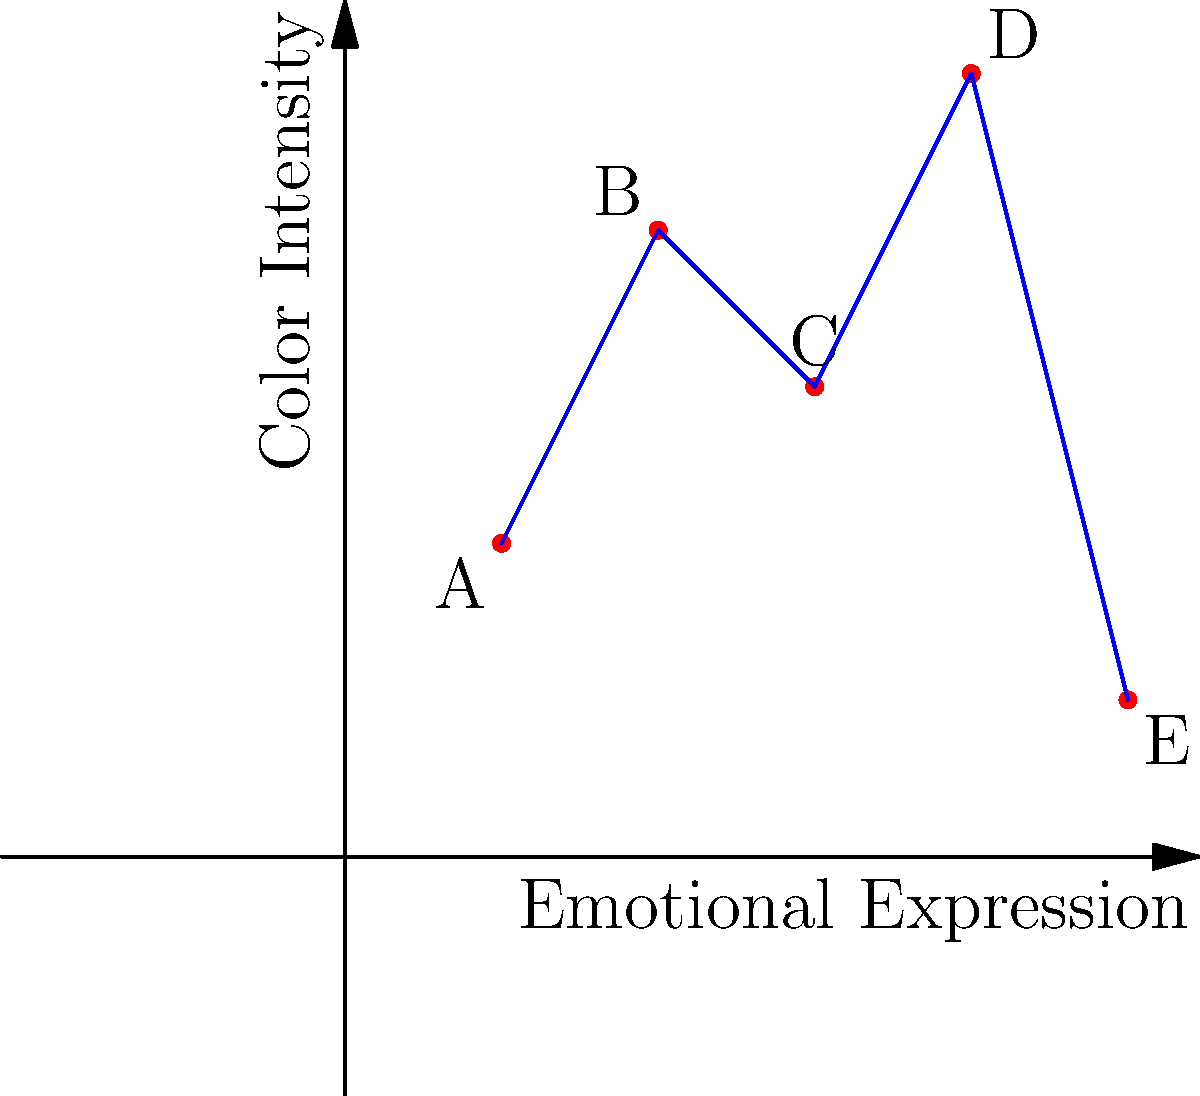The graph above represents the relationship between emotional expression and color intensity in children's artwork. Each point (A, B, C, D, E) corresponds to a different child's drawing. Which point is most likely to indicate potential trauma based on the combination of high emotional expression and high color intensity? To answer this question, we need to analyze the graph and understand the relationship between emotional expression and color intensity in the context of trauma indicators in children's artwork. Let's break it down step-by-step:

1. Understand the axes:
   - X-axis represents Emotional Expression
   - Y-axis represents Color Intensity

2. Interpret the relationship:
   - Higher values on both axes indicate stronger emotional expression and more intense color use.
   - In trauma-related artwork, children often express intense emotions and use vivid colors.

3. Analyze each point:
   A (1,2): Low emotional expression, low color intensity
   B (2,4): Moderate emotional expression, high color intensity
   C (3,3): Moderate emotional expression, moderate color intensity
   D (4,5): High emotional expression, high color intensity
   E (5,1): High emotional expression, low color intensity

4. Identify the point with high values on both axes:
   Point D (4,5) shows the highest combination of emotional expression and color intensity.

5. Relate to trauma indicators:
   High emotional expression combined with intense color use can be indicative of trauma or strong emotional distress in children's artwork.

Therefore, point D is most likely to indicate potential trauma based on the combination of high emotional expression and high color intensity.
Answer: Point D 